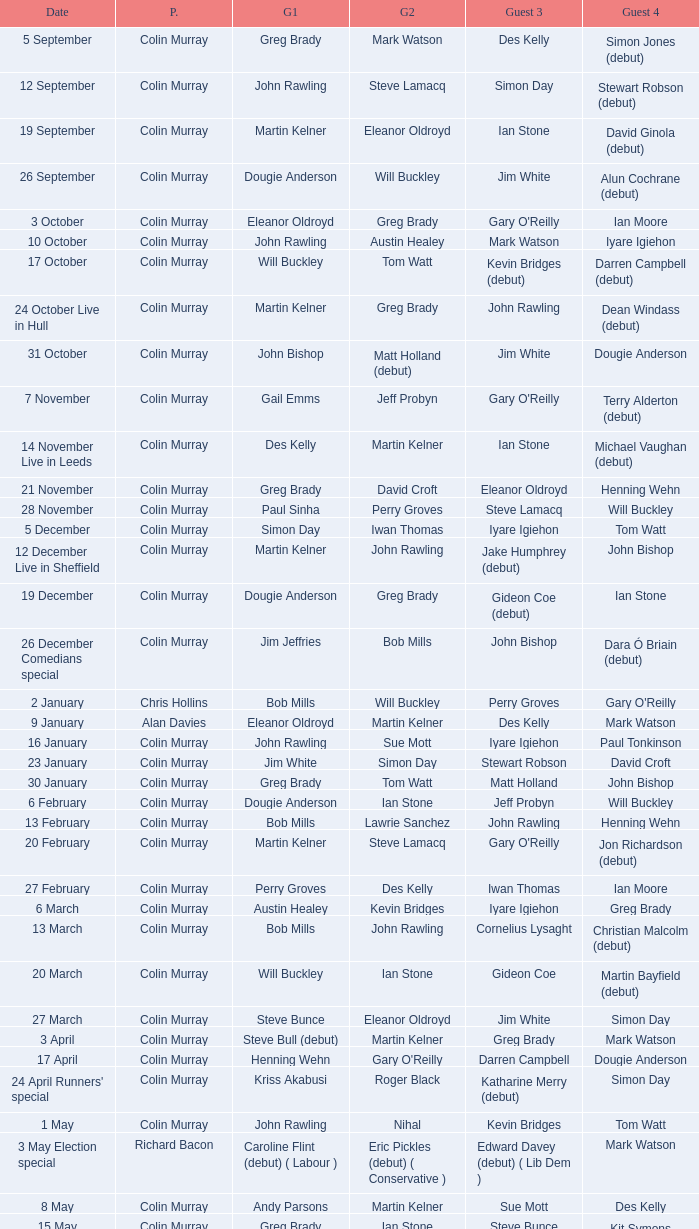How many people are guest 1 on episodes where guest 4 is Des Kelly? 1.0. 